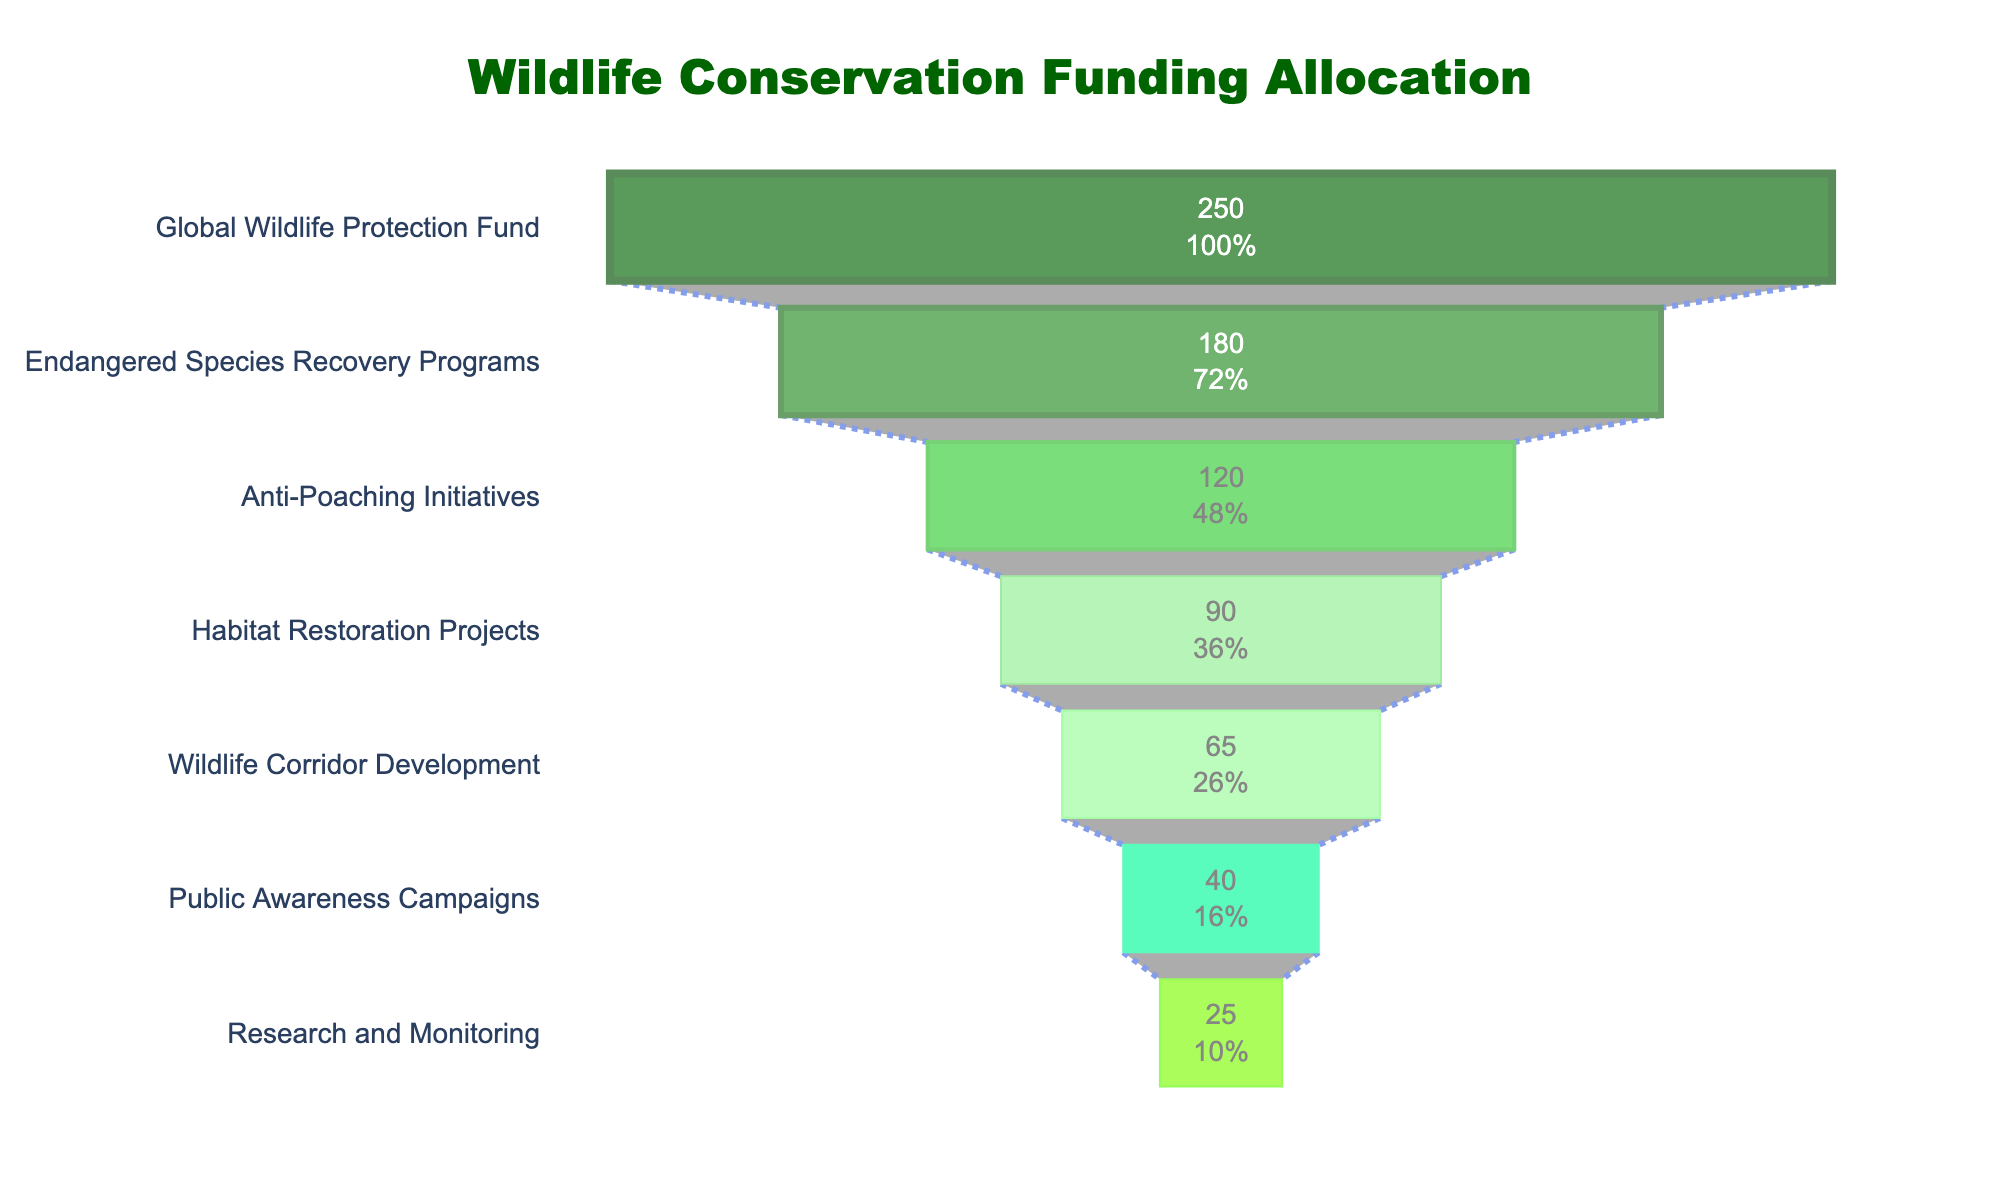What is the total funding for Wildlife conservation initiatives? Add up the funding amounts listed for each initiative: 250 + 180 + 120 + 90 + 65 + 40 + 25 = 770 million USD.
Answer: 770 million USD Which initiative received the highest funding? The initiative at the top of the funnel (Global Wildlife Protection Fund) has the highest funding, according to the figure labeling.
Answer: Global Wildlife Protection Fund What percentage of the total funding is allocated to the Anti-Poaching Initiatives? The Anti-Poaching Initiatives received 120 million USD. To find the percentage: (120 / 770) * 100 = approximately 15.6%.
Answer: Approximately 15.6% How does the funding for Public Awareness Campaigns compare to Research and Monitoring? Public Awareness Campaigns received 40 million USD, while Research and Monitoring received 25 million USD. 40 is greater than 25, so Public Awareness Campaigns received more funding.
Answer: Public Awareness Campaigns received more funding If the primary concern is habitat restoration, which other initiative(s) received less funding than Habitat Restoration Projects? Habitat Restoration Projects received 90 million USD. Initiatives that received less include Wildlife Corridor Development (65 million), Public Awareness Campaigns (40 million), and Research and Monitoring (25 million).
Answer: Wildlife Corridor Development, Public Awareness Campaigns, Research and Monitoring What is the difference in funding between the top-funded and the least-funded initiatives? The top-funded initiative (Global Wildlife Protection Fund) received 250 million USD, and the least-funded initiative (Research and Monitoring) received 25 million USD. The difference is 250 - 25 = 225 million USD.
Answer: 225 million USD What fraction of the total funding is allocated to Habitat Restoration Projects and Wildlife Corridor Development combined? The combined funding for these two initiatives is 90 + 65 = 155 million USD. To find the fraction: 155 / 770 = 0.2013 or approximately 20.13%.
Answer: Approximately 20.13% What is shared by all the initiatives in the chart? All the initiatives are part of Wildlife Conservation Funding Allocation. They vary in funding amounts but are collectively aimed at different conservation efforts.
Answer: They are all part of Wildlife Conservation Funding Allocation Among the initiatives, which one requires the largest gap in additional funding to meet the highest-funded initiative? Calculating the gap: Global Wildlife Protection Fund (250 million USD) minus each respective initiative: 250 - 180, 250 - 120, 250 - 90, 250 - 65, 250 - 40, 250 - 25. The largest gap is between Global Wildlife Protection Fund and Research and Monitoring, which is 250 - 25 = 225 million USD.
Answer: Research and Monitoring with 225 million USD Which initiatives received equal or more than 100 million USD in funding? The initiatives that received equal or more than 100 million USD are Global Wildlife Protection Fund (250), Endangered Species Recovery Programs (180), and Anti-Poaching Initiatives (120).
Answer: Global Wildlife Protection Fund, Endangered Species Recovery Programs, Anti-Poaching Initiatives 